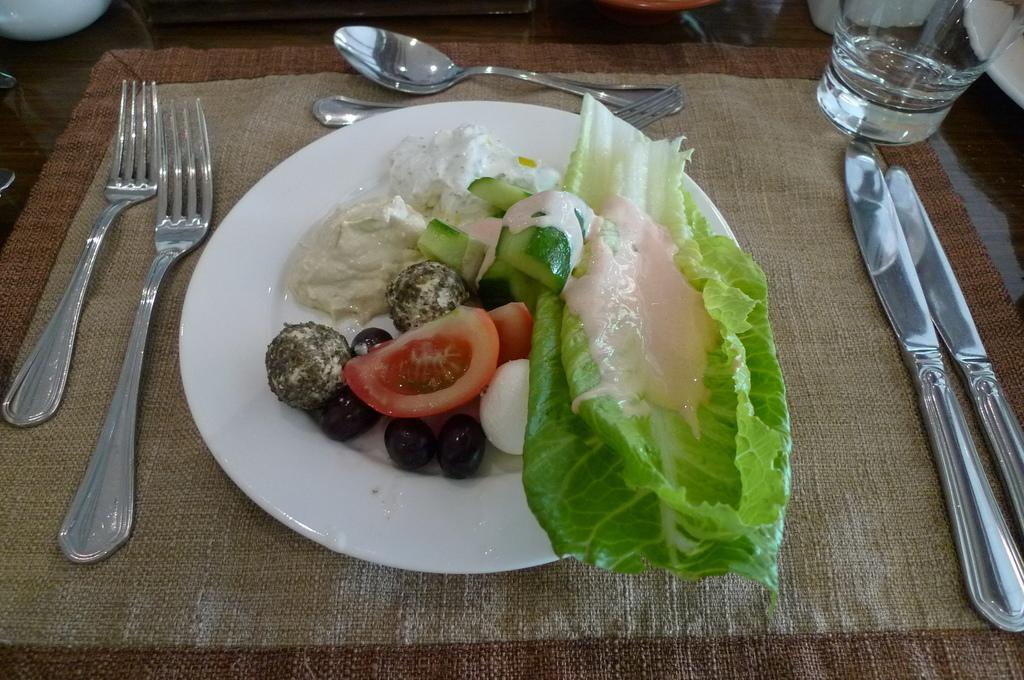Can you describe this image briefly? In this image I can see a white colour plate and on it I can see different types of food. On the right side of this image I can see a glass, two knives and on the left side I can see two forks. On the top side of this image i can see a spoon and one more fork. I can also see few white colour things on the both top corners of this image. 